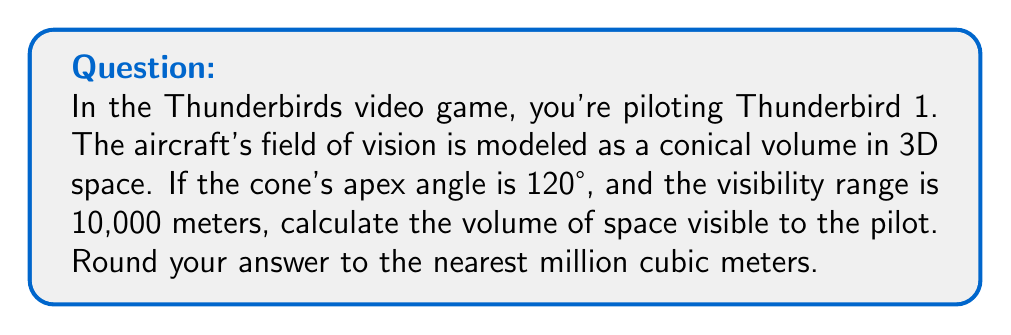Help me with this question. Let's approach this step-by-step:

1) The field of vision forms a cone. We need to calculate its volume.

2) The formula for the volume of a cone is:

   $$V = \frac{1}{3}\pi r^2 h$$

   where $r$ is the radius of the base and $h$ is the height.

3) We're given the visibility range (height of the cone) $h = 10,000$ meters.

4) We need to find the radius $r$. We can do this using the apex angle:

   The apex angle is 120°, so half of this is 60°.

5) In a right triangle formed by the height and radius:

   $$\tan 60° = \frac{r}{h}$$

6) We know that $\tan 60° = \sqrt{3}$, so:

   $$r = h \tan 60° = 10,000 \sqrt{3}$$

7) Now we can substitute into our volume formula:

   $$V = \frac{1}{3}\pi (10,000\sqrt{3})^2 10,000$$

8) Simplify:

   $$V = \frac{1}{3}\pi \cdot 300,000,000 \cdot 10,000$$
   
   $$V = 1,000,000,000,000\pi$$

9) Calculate and round to the nearest million:

   $$V \approx 3,141,592,654,000 \approx 3,142,000,000,000$$ cubic meters
Answer: 3,142,000,000,000 cubic meters 